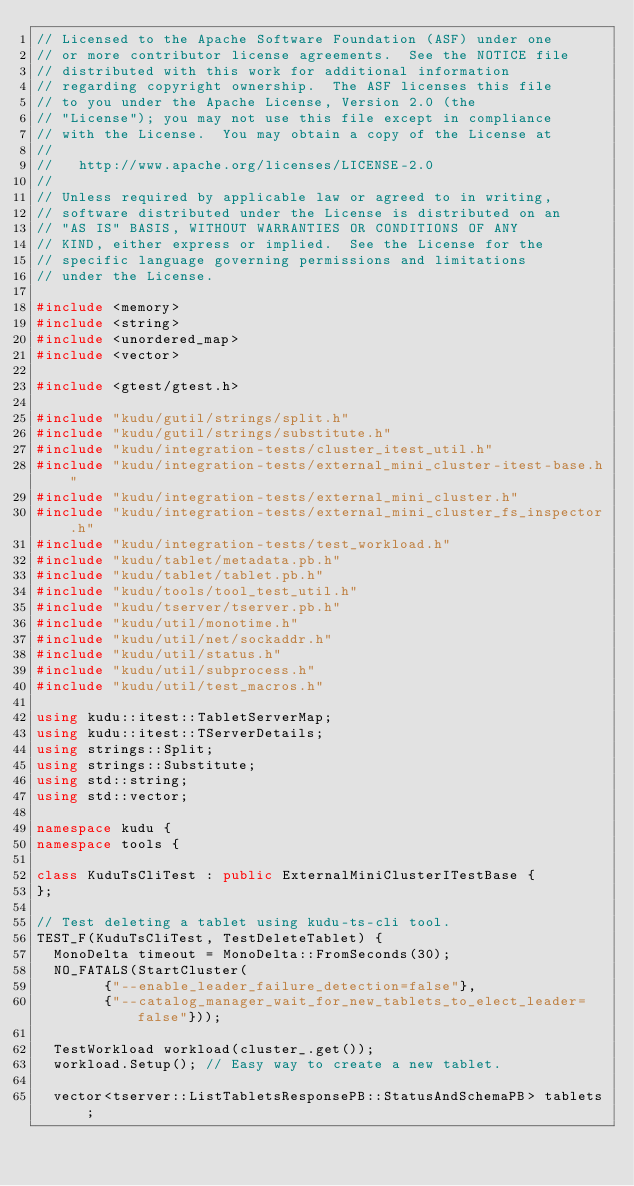<code> <loc_0><loc_0><loc_500><loc_500><_C++_>// Licensed to the Apache Software Foundation (ASF) under one
// or more contributor license agreements.  See the NOTICE file
// distributed with this work for additional information
// regarding copyright ownership.  The ASF licenses this file
// to you under the Apache License, Version 2.0 (the
// "License"); you may not use this file except in compliance
// with the License.  You may obtain a copy of the License at
//
//   http://www.apache.org/licenses/LICENSE-2.0
//
// Unless required by applicable law or agreed to in writing,
// software distributed under the License is distributed on an
// "AS IS" BASIS, WITHOUT WARRANTIES OR CONDITIONS OF ANY
// KIND, either express or implied.  See the License for the
// specific language governing permissions and limitations
// under the License.

#include <memory>
#include <string>
#include <unordered_map>
#include <vector>

#include <gtest/gtest.h>

#include "kudu/gutil/strings/split.h"
#include "kudu/gutil/strings/substitute.h"
#include "kudu/integration-tests/cluster_itest_util.h"
#include "kudu/integration-tests/external_mini_cluster-itest-base.h"
#include "kudu/integration-tests/external_mini_cluster.h"
#include "kudu/integration-tests/external_mini_cluster_fs_inspector.h"
#include "kudu/integration-tests/test_workload.h"
#include "kudu/tablet/metadata.pb.h"
#include "kudu/tablet/tablet.pb.h"
#include "kudu/tools/tool_test_util.h"
#include "kudu/tserver/tserver.pb.h"
#include "kudu/util/monotime.h"
#include "kudu/util/net/sockaddr.h"
#include "kudu/util/status.h"
#include "kudu/util/subprocess.h"
#include "kudu/util/test_macros.h"

using kudu::itest::TabletServerMap;
using kudu::itest::TServerDetails;
using strings::Split;
using strings::Substitute;
using std::string;
using std::vector;

namespace kudu {
namespace tools {

class KuduTsCliTest : public ExternalMiniClusterITestBase {
};

// Test deleting a tablet using kudu-ts-cli tool.
TEST_F(KuduTsCliTest, TestDeleteTablet) {
  MonoDelta timeout = MonoDelta::FromSeconds(30);
  NO_FATALS(StartCluster(
        {"--enable_leader_failure_detection=false"},
        {"--catalog_manager_wait_for_new_tablets_to_elect_leader=false"}));

  TestWorkload workload(cluster_.get());
  workload.Setup(); // Easy way to create a new tablet.

  vector<tserver::ListTabletsResponsePB::StatusAndSchemaPB> tablets;</code> 